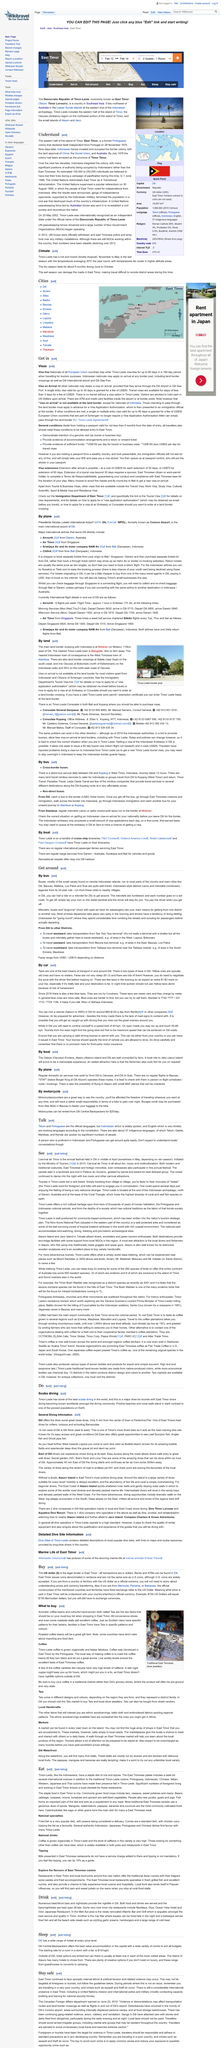Draw attention to some important aspects in this diagram. The official currency used in East Timor are the US dollar for notes and the East Timor Centavo for coins, with the United States dollar coins not being used. Roasted coffee beans are a great gift item that can be enjoyed by anyone. The democratic republic of Timor-Leste, commonly known as East Timor, is a country located in Southeast Asia. On November 28th, 1975, East Timor declared its independence from Portugal. Upon arrival in Indonesia for a single-entry visit, US nationals are granted a 30-day visa for a fee of $30, which should be paid in US Dollars. 